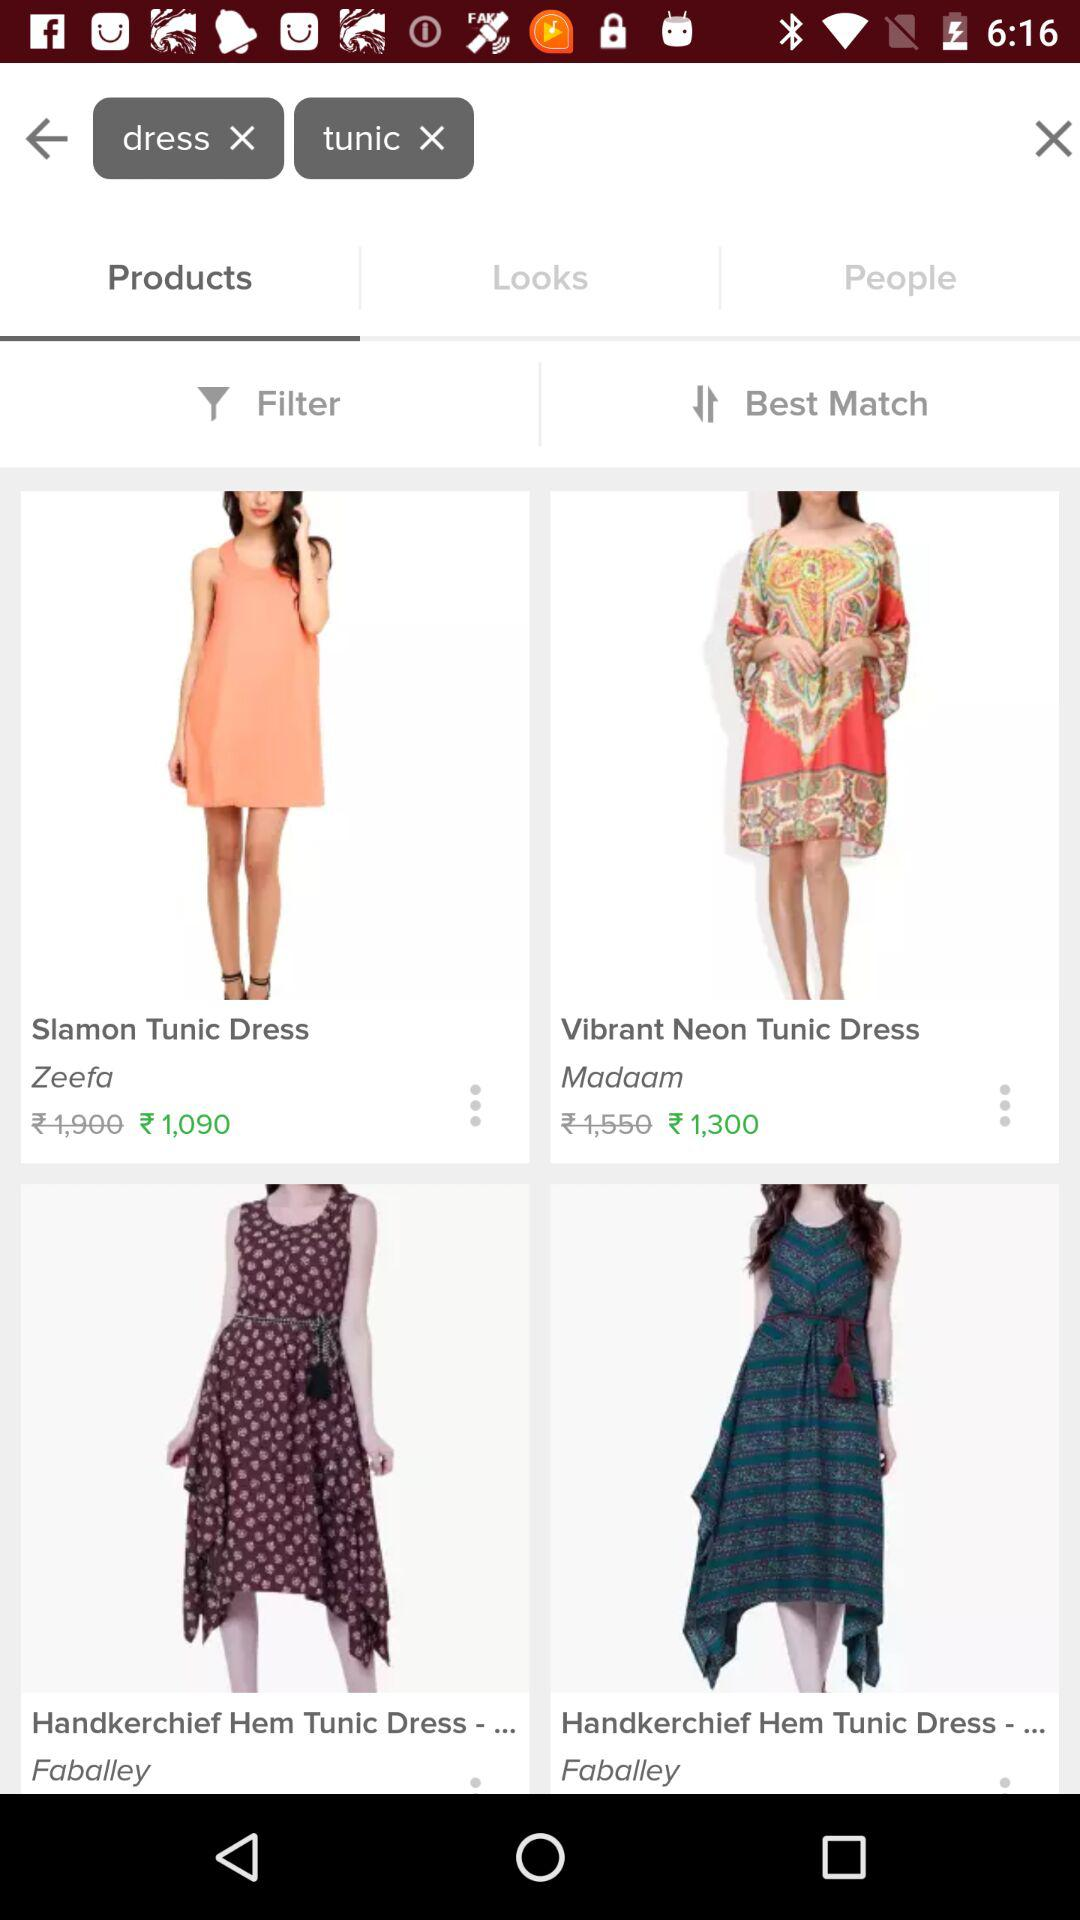What is the discounted price of the "Slamon Tunic Dress"? The discounted price is ₹1,090. 